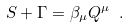<formula> <loc_0><loc_0><loc_500><loc_500>S + \Gamma = \beta _ { \mu } Q ^ { \mu } \ .</formula> 